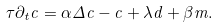Convert formula to latex. <formula><loc_0><loc_0><loc_500><loc_500>\tau \partial _ { t } c = \alpha \Delta c - c + \lambda d + \beta m .</formula> 